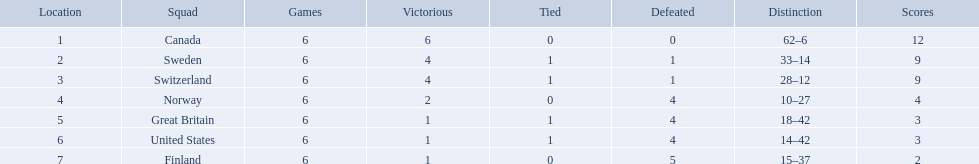Which are the two countries? Switzerland, Great Britain. What were the point totals for each of these countries? 9, 3. Of these point totals, which is better? 9. Which country earned this point total? Switzerland. 